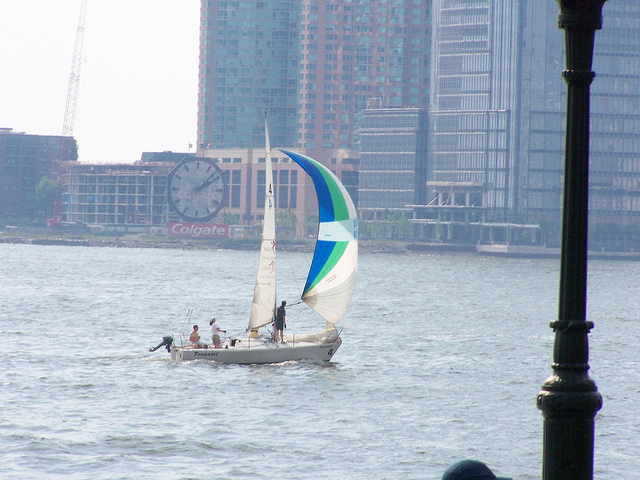What does the skyline suggest about the location in the image? The skyline is characterized by modern high-rise buildings and a well-developed waterfront area, which suggests an urban and economically developed location. The presence of the sailboat and the recreational nature of sailing imply that this body of water is likely situated near a city that not only values its waterfront space but also offers leisure activities to its inhabitants and visitors. 